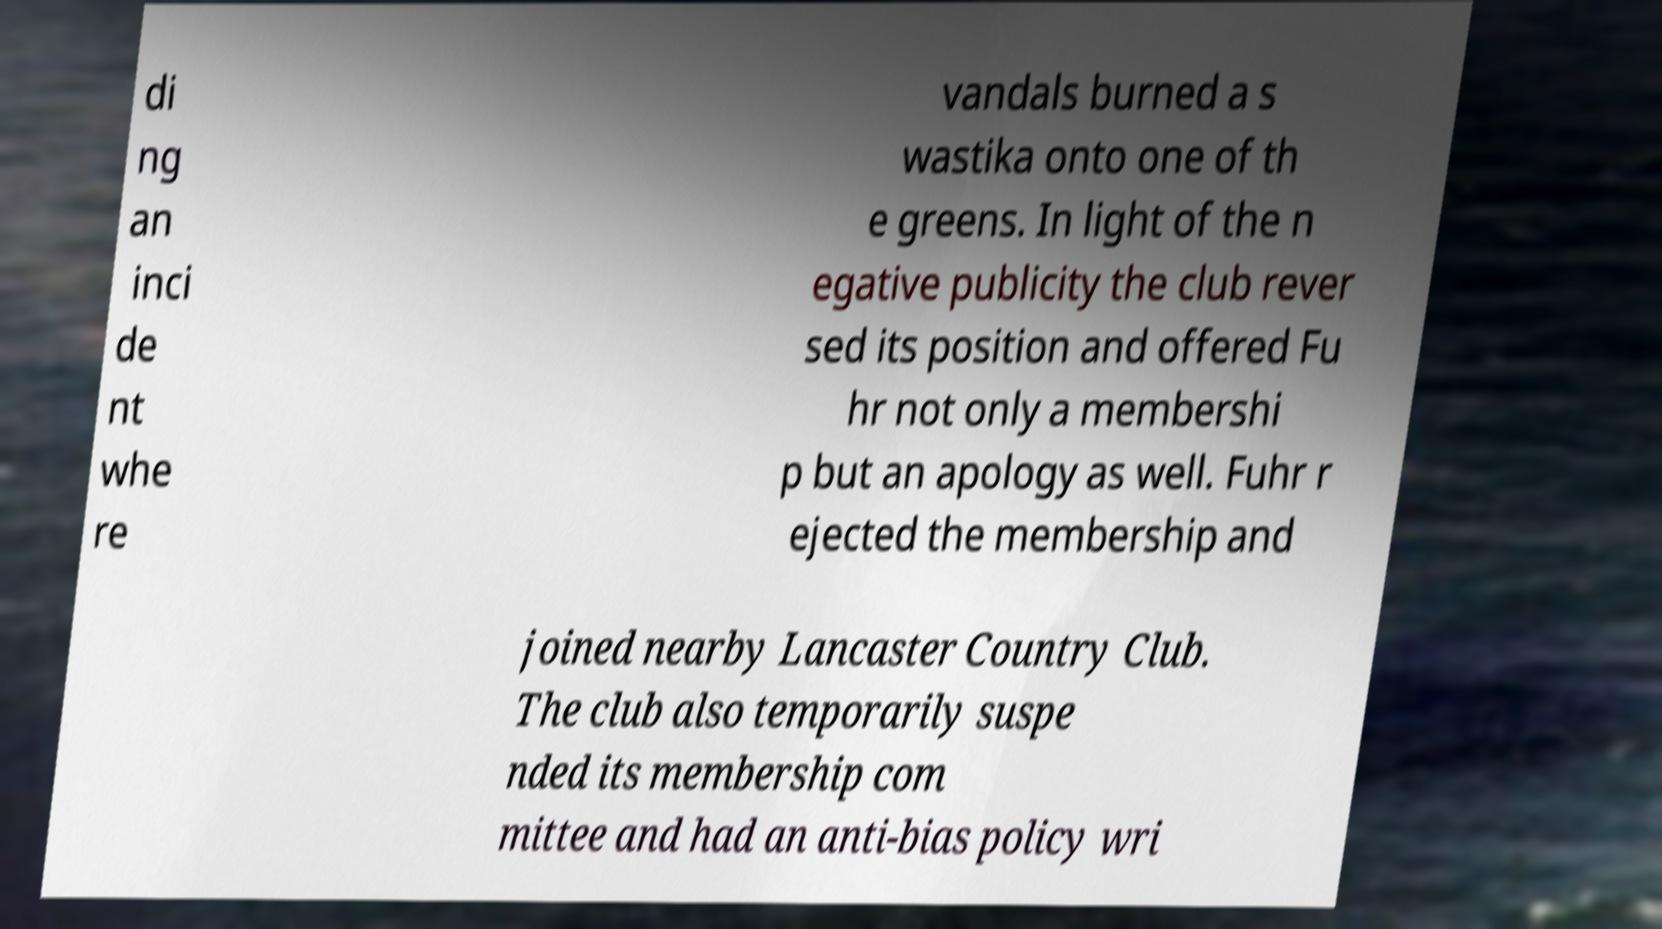What messages or text are displayed in this image? I need them in a readable, typed format. di ng an inci de nt whe re vandals burned a s wastika onto one of th e greens. In light of the n egative publicity the club rever sed its position and offered Fu hr not only a membershi p but an apology as well. Fuhr r ejected the membership and joined nearby Lancaster Country Club. The club also temporarily suspe nded its membership com mittee and had an anti-bias policy wri 